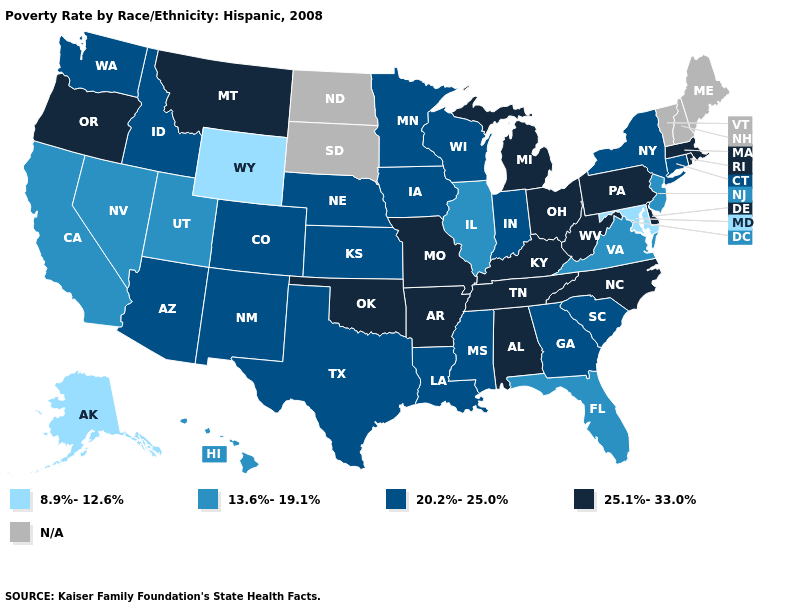Does the first symbol in the legend represent the smallest category?
Quick response, please. Yes. Among the states that border Delaware , does Maryland have the highest value?
Keep it brief. No. Which states have the lowest value in the USA?
Keep it brief. Alaska, Maryland, Wyoming. What is the lowest value in the Northeast?
Quick response, please. 13.6%-19.1%. What is the value of Wisconsin?
Write a very short answer. 20.2%-25.0%. Is the legend a continuous bar?
Answer briefly. No. Name the states that have a value in the range 20.2%-25.0%?
Keep it brief. Arizona, Colorado, Connecticut, Georgia, Idaho, Indiana, Iowa, Kansas, Louisiana, Minnesota, Mississippi, Nebraska, New Mexico, New York, South Carolina, Texas, Washington, Wisconsin. What is the value of Alabama?
Be succinct. 25.1%-33.0%. Does the map have missing data?
Keep it brief. Yes. Among the states that border Michigan , which have the lowest value?
Concise answer only. Indiana, Wisconsin. What is the value of Rhode Island?
Give a very brief answer. 25.1%-33.0%. Does the first symbol in the legend represent the smallest category?
Short answer required. Yes. 